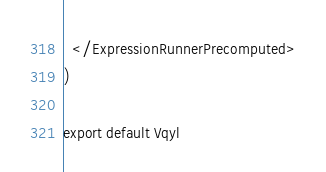<code> <loc_0><loc_0><loc_500><loc_500><_TypeScript_>  </ExpressionRunnerPrecomputed>
)

export default Vqyl
</code> 